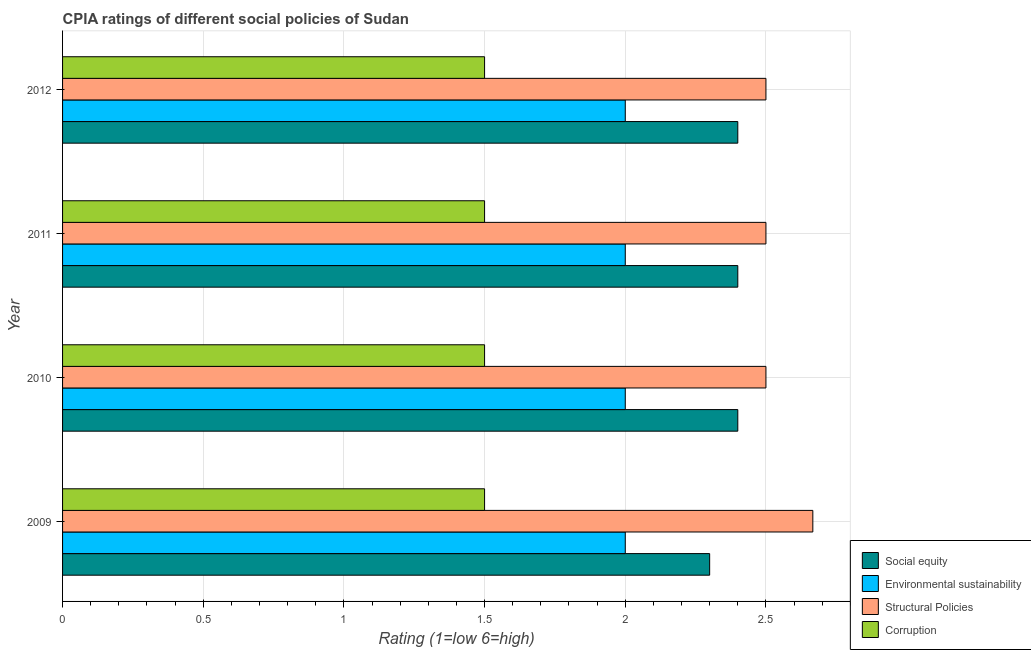How many different coloured bars are there?
Your response must be concise. 4. How many groups of bars are there?
Your answer should be very brief. 4. Are the number of bars per tick equal to the number of legend labels?
Your answer should be compact. Yes. In how many cases, is the number of bars for a given year not equal to the number of legend labels?
Provide a short and direct response. 0. What is the total cpia rating of corruption in the graph?
Your response must be concise. 6. What is the difference between the cpia rating of social equity in 2009 and the cpia rating of structural policies in 2012?
Your answer should be very brief. -0.2. In the year 2009, what is the difference between the cpia rating of environmental sustainability and cpia rating of structural policies?
Provide a succinct answer. -0.67. In how many years, is the cpia rating of environmental sustainability greater than 1 ?
Ensure brevity in your answer.  4. What is the ratio of the cpia rating of social equity in 2009 to that in 2011?
Your answer should be compact. 0.96. Is the difference between the cpia rating of corruption in 2009 and 2011 greater than the difference between the cpia rating of structural policies in 2009 and 2011?
Make the answer very short. No. What is the difference between the highest and the second highest cpia rating of structural policies?
Provide a short and direct response. 0.17. In how many years, is the cpia rating of environmental sustainability greater than the average cpia rating of environmental sustainability taken over all years?
Your answer should be compact. 0. What does the 4th bar from the top in 2012 represents?
Keep it short and to the point. Social equity. What does the 2nd bar from the bottom in 2011 represents?
Offer a very short reply. Environmental sustainability. Is it the case that in every year, the sum of the cpia rating of social equity and cpia rating of environmental sustainability is greater than the cpia rating of structural policies?
Your answer should be very brief. Yes. How many bars are there?
Give a very brief answer. 16. What is the difference between two consecutive major ticks on the X-axis?
Provide a succinct answer. 0.5. Are the values on the major ticks of X-axis written in scientific E-notation?
Keep it short and to the point. No. Does the graph contain any zero values?
Keep it short and to the point. No. How many legend labels are there?
Keep it short and to the point. 4. What is the title of the graph?
Make the answer very short. CPIA ratings of different social policies of Sudan. Does "Macroeconomic management" appear as one of the legend labels in the graph?
Ensure brevity in your answer.  No. What is the Rating (1=low 6=high) in Social equity in 2009?
Provide a succinct answer. 2.3. What is the Rating (1=low 6=high) of Structural Policies in 2009?
Offer a terse response. 2.67. What is the Rating (1=low 6=high) of Corruption in 2009?
Your answer should be compact. 1.5. What is the Rating (1=low 6=high) in Social equity in 2010?
Your response must be concise. 2.4. What is the Rating (1=low 6=high) of Environmental sustainability in 2011?
Give a very brief answer. 2. What is the Rating (1=low 6=high) in Structural Policies in 2011?
Offer a very short reply. 2.5. What is the Rating (1=low 6=high) in Social equity in 2012?
Your answer should be very brief. 2.4. What is the Rating (1=low 6=high) of Structural Policies in 2012?
Your response must be concise. 2.5. What is the Rating (1=low 6=high) of Corruption in 2012?
Keep it short and to the point. 1.5. Across all years, what is the maximum Rating (1=low 6=high) in Structural Policies?
Give a very brief answer. 2.67. Across all years, what is the maximum Rating (1=low 6=high) of Corruption?
Make the answer very short. 1.5. Across all years, what is the minimum Rating (1=low 6=high) in Environmental sustainability?
Give a very brief answer. 2. Across all years, what is the minimum Rating (1=low 6=high) in Structural Policies?
Your answer should be compact. 2.5. Across all years, what is the minimum Rating (1=low 6=high) in Corruption?
Provide a short and direct response. 1.5. What is the total Rating (1=low 6=high) of Environmental sustainability in the graph?
Offer a terse response. 8. What is the total Rating (1=low 6=high) of Structural Policies in the graph?
Your answer should be compact. 10.17. What is the total Rating (1=low 6=high) of Corruption in the graph?
Offer a very short reply. 6. What is the difference between the Rating (1=low 6=high) in Social equity in 2009 and that in 2010?
Ensure brevity in your answer.  -0.1. What is the difference between the Rating (1=low 6=high) in Corruption in 2009 and that in 2010?
Make the answer very short. 0. What is the difference between the Rating (1=low 6=high) of Environmental sustainability in 2009 and that in 2011?
Offer a terse response. 0. What is the difference between the Rating (1=low 6=high) in Structural Policies in 2009 and that in 2011?
Give a very brief answer. 0.17. What is the difference between the Rating (1=low 6=high) in Corruption in 2009 and that in 2011?
Offer a terse response. 0. What is the difference between the Rating (1=low 6=high) of Environmental sustainability in 2010 and that in 2011?
Your response must be concise. 0. What is the difference between the Rating (1=low 6=high) of Corruption in 2010 and that in 2011?
Provide a short and direct response. 0. What is the difference between the Rating (1=low 6=high) in Social equity in 2010 and that in 2012?
Offer a very short reply. 0. What is the difference between the Rating (1=low 6=high) in Structural Policies in 2010 and that in 2012?
Keep it short and to the point. 0. What is the difference between the Rating (1=low 6=high) of Social equity in 2011 and that in 2012?
Offer a terse response. 0. What is the difference between the Rating (1=low 6=high) of Structural Policies in 2011 and that in 2012?
Ensure brevity in your answer.  0. What is the difference between the Rating (1=low 6=high) in Social equity in 2009 and the Rating (1=low 6=high) in Structural Policies in 2010?
Provide a succinct answer. -0.2. What is the difference between the Rating (1=low 6=high) in Social equity in 2009 and the Rating (1=low 6=high) in Corruption in 2010?
Provide a succinct answer. 0.8. What is the difference between the Rating (1=low 6=high) of Environmental sustainability in 2009 and the Rating (1=low 6=high) of Structural Policies in 2010?
Keep it short and to the point. -0.5. What is the difference between the Rating (1=low 6=high) of Social equity in 2009 and the Rating (1=low 6=high) of Environmental sustainability in 2011?
Provide a succinct answer. 0.3. What is the difference between the Rating (1=low 6=high) in Social equity in 2009 and the Rating (1=low 6=high) in Corruption in 2011?
Your response must be concise. 0.8. What is the difference between the Rating (1=low 6=high) in Social equity in 2010 and the Rating (1=low 6=high) in Structural Policies in 2011?
Your answer should be very brief. -0.1. What is the difference between the Rating (1=low 6=high) in Environmental sustainability in 2010 and the Rating (1=low 6=high) in Structural Policies in 2011?
Give a very brief answer. -0.5. What is the difference between the Rating (1=low 6=high) in Environmental sustainability in 2010 and the Rating (1=low 6=high) in Corruption in 2011?
Offer a very short reply. 0.5. What is the difference between the Rating (1=low 6=high) of Structural Policies in 2010 and the Rating (1=low 6=high) of Corruption in 2011?
Offer a terse response. 1. What is the difference between the Rating (1=low 6=high) in Social equity in 2010 and the Rating (1=low 6=high) in Corruption in 2012?
Ensure brevity in your answer.  0.9. What is the difference between the Rating (1=low 6=high) of Structural Policies in 2010 and the Rating (1=low 6=high) of Corruption in 2012?
Make the answer very short. 1. What is the difference between the Rating (1=low 6=high) of Social equity in 2011 and the Rating (1=low 6=high) of Environmental sustainability in 2012?
Your answer should be compact. 0.4. What is the difference between the Rating (1=low 6=high) in Social equity in 2011 and the Rating (1=low 6=high) in Corruption in 2012?
Provide a short and direct response. 0.9. What is the difference between the Rating (1=low 6=high) of Environmental sustainability in 2011 and the Rating (1=low 6=high) of Corruption in 2012?
Ensure brevity in your answer.  0.5. What is the average Rating (1=low 6=high) of Social equity per year?
Give a very brief answer. 2.38. What is the average Rating (1=low 6=high) in Environmental sustainability per year?
Provide a succinct answer. 2. What is the average Rating (1=low 6=high) of Structural Policies per year?
Offer a very short reply. 2.54. In the year 2009, what is the difference between the Rating (1=low 6=high) of Social equity and Rating (1=low 6=high) of Structural Policies?
Keep it short and to the point. -0.37. In the year 2009, what is the difference between the Rating (1=low 6=high) of Social equity and Rating (1=low 6=high) of Corruption?
Keep it short and to the point. 0.8. In the year 2009, what is the difference between the Rating (1=low 6=high) in Environmental sustainability and Rating (1=low 6=high) in Structural Policies?
Give a very brief answer. -0.67. In the year 2010, what is the difference between the Rating (1=low 6=high) of Social equity and Rating (1=low 6=high) of Environmental sustainability?
Your response must be concise. 0.4. In the year 2010, what is the difference between the Rating (1=low 6=high) in Social equity and Rating (1=low 6=high) in Structural Policies?
Your answer should be very brief. -0.1. In the year 2011, what is the difference between the Rating (1=low 6=high) of Social equity and Rating (1=low 6=high) of Environmental sustainability?
Your response must be concise. 0.4. In the year 2011, what is the difference between the Rating (1=low 6=high) in Social equity and Rating (1=low 6=high) in Structural Policies?
Ensure brevity in your answer.  -0.1. In the year 2011, what is the difference between the Rating (1=low 6=high) of Social equity and Rating (1=low 6=high) of Corruption?
Provide a short and direct response. 0.9. In the year 2011, what is the difference between the Rating (1=low 6=high) of Environmental sustainability and Rating (1=low 6=high) of Structural Policies?
Your answer should be compact. -0.5. In the year 2011, what is the difference between the Rating (1=low 6=high) of Structural Policies and Rating (1=low 6=high) of Corruption?
Provide a short and direct response. 1. In the year 2012, what is the difference between the Rating (1=low 6=high) of Social equity and Rating (1=low 6=high) of Environmental sustainability?
Offer a very short reply. 0.4. In the year 2012, what is the difference between the Rating (1=low 6=high) in Social equity and Rating (1=low 6=high) in Structural Policies?
Make the answer very short. -0.1. In the year 2012, what is the difference between the Rating (1=low 6=high) of Social equity and Rating (1=low 6=high) of Corruption?
Give a very brief answer. 0.9. In the year 2012, what is the difference between the Rating (1=low 6=high) in Environmental sustainability and Rating (1=low 6=high) in Structural Policies?
Your answer should be compact. -0.5. In the year 2012, what is the difference between the Rating (1=low 6=high) in Environmental sustainability and Rating (1=low 6=high) in Corruption?
Your response must be concise. 0.5. In the year 2012, what is the difference between the Rating (1=low 6=high) of Structural Policies and Rating (1=low 6=high) of Corruption?
Provide a short and direct response. 1. What is the ratio of the Rating (1=low 6=high) in Environmental sustainability in 2009 to that in 2010?
Keep it short and to the point. 1. What is the ratio of the Rating (1=low 6=high) of Structural Policies in 2009 to that in 2010?
Your response must be concise. 1.07. What is the ratio of the Rating (1=low 6=high) in Corruption in 2009 to that in 2010?
Provide a succinct answer. 1. What is the ratio of the Rating (1=low 6=high) of Structural Policies in 2009 to that in 2011?
Provide a succinct answer. 1.07. What is the ratio of the Rating (1=low 6=high) of Corruption in 2009 to that in 2011?
Your answer should be compact. 1. What is the ratio of the Rating (1=low 6=high) of Environmental sustainability in 2009 to that in 2012?
Ensure brevity in your answer.  1. What is the ratio of the Rating (1=low 6=high) of Structural Policies in 2009 to that in 2012?
Offer a terse response. 1.07. What is the ratio of the Rating (1=low 6=high) in Structural Policies in 2011 to that in 2012?
Ensure brevity in your answer.  1. What is the ratio of the Rating (1=low 6=high) of Corruption in 2011 to that in 2012?
Your response must be concise. 1. What is the difference between the highest and the second highest Rating (1=low 6=high) of Social equity?
Give a very brief answer. 0. What is the difference between the highest and the lowest Rating (1=low 6=high) of Social equity?
Provide a short and direct response. 0.1. What is the difference between the highest and the lowest Rating (1=low 6=high) in Structural Policies?
Your response must be concise. 0.17. What is the difference between the highest and the lowest Rating (1=low 6=high) in Corruption?
Your response must be concise. 0. 